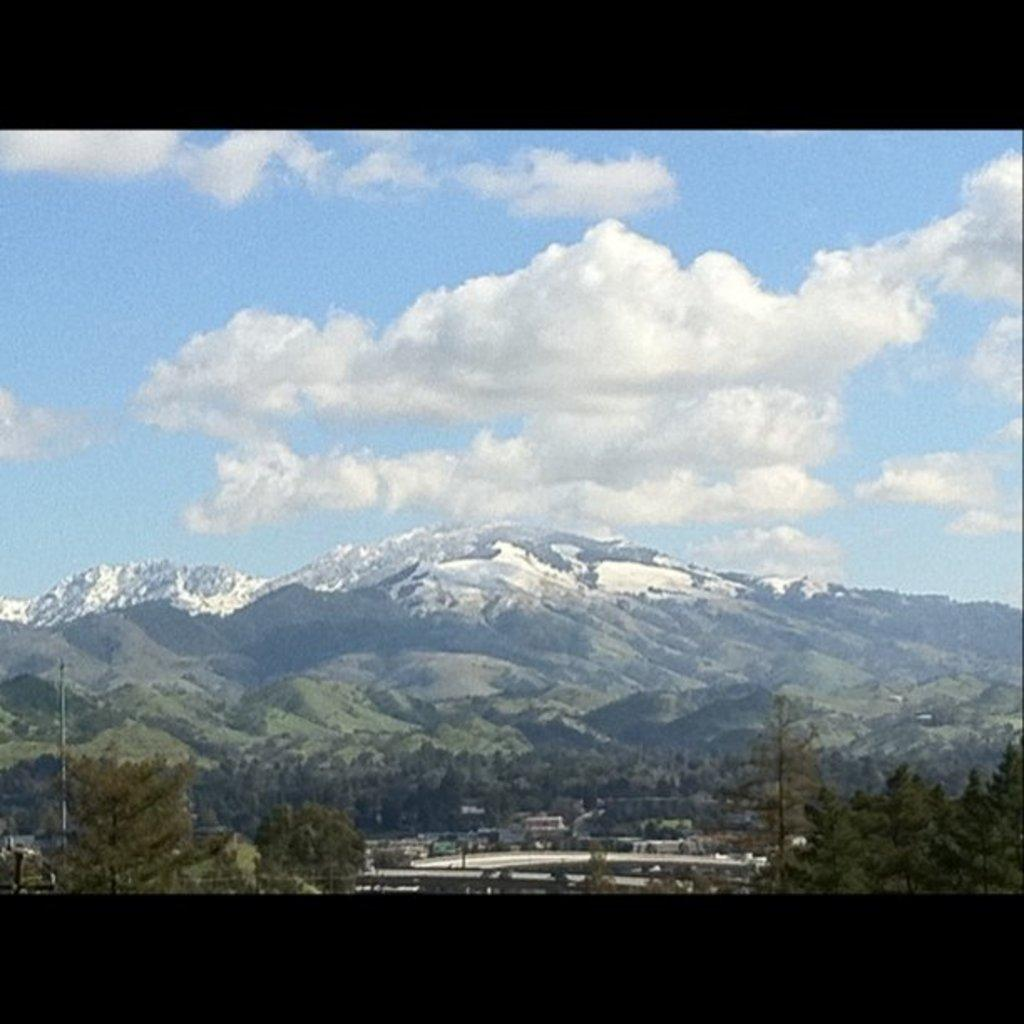What is the main structure in the image? There is a pole in the image. What type of natural elements can be seen in the image? There are trees and hills in the image. What else is present in the image besides the pole and natural elements? There are some items in the image. How would you describe the weather in the image? The sky is cloudy in the image. How many cabbages are hanging from the pole in the image? There are no cabbages present in the image, and therefore none are hanging from the pole. 